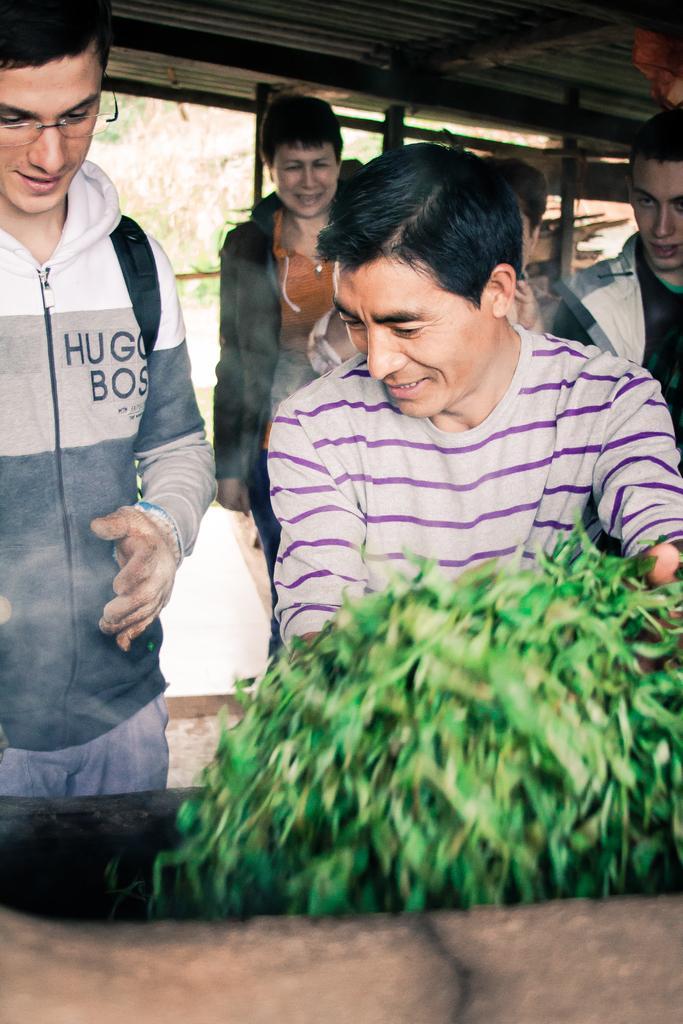Could you give a brief overview of what you see in this image? In this picture we can see a group of people standing on the ground and smiling, plant and in the background we can see pillars. 